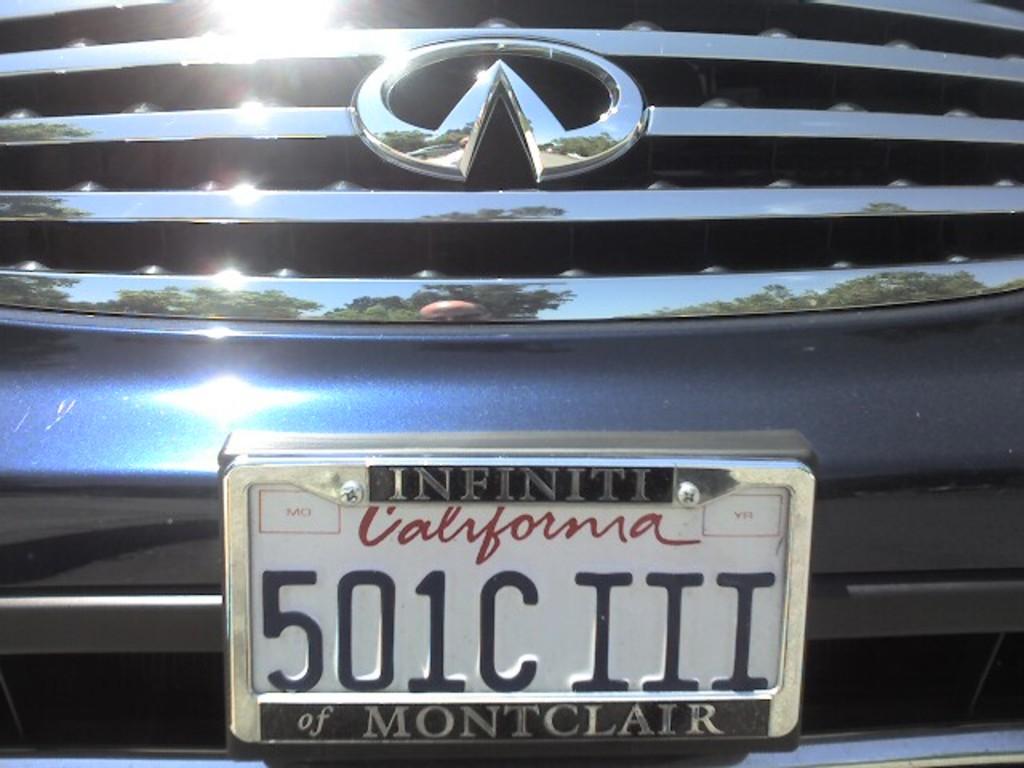What state is on the license plate?
Make the answer very short. California. What are the numbers on the license plate?
Ensure brevity in your answer.  501. 